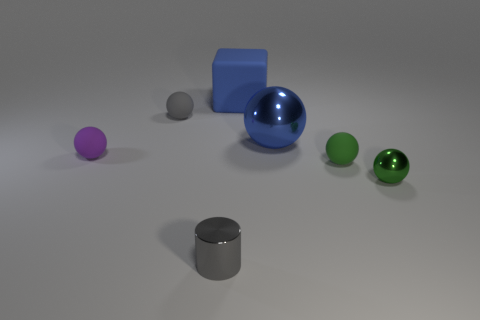There is a ball that is the same color as the big matte object; what is its material?
Provide a succinct answer. Metal. Does the blue sphere have the same size as the green rubber sphere?
Provide a short and direct response. No. There is a sphere on the left side of the tiny gray ball; what is it made of?
Make the answer very short. Rubber. What material is the tiny gray thing that is the same shape as the purple object?
Make the answer very short. Rubber. There is a tiny sphere behind the purple matte sphere; are there any blue metal objects that are on the left side of it?
Provide a succinct answer. No. Is the large metallic object the same shape as the green metallic object?
Provide a succinct answer. Yes. There is a large thing that is the same material as the small gray ball; what shape is it?
Make the answer very short. Cube. Do the matte object that is right of the blue matte thing and the metal ball behind the tiny metallic ball have the same size?
Offer a terse response. No. Is the number of blue things that are in front of the blue cube greater than the number of tiny green rubber things that are in front of the tiny green rubber sphere?
Offer a very short reply. Yes. How many other things are the same color as the big block?
Make the answer very short. 1. 